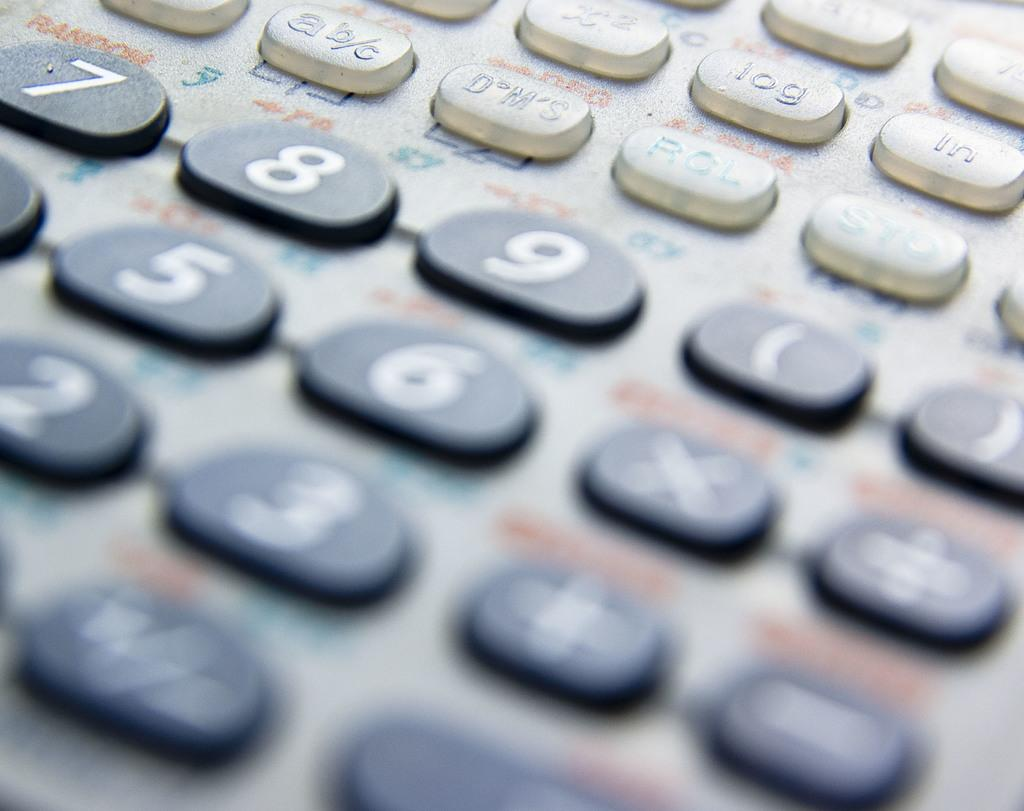<image>
Share a concise interpretation of the image provided. A calculator contains a number of keys including digits such as 7. 